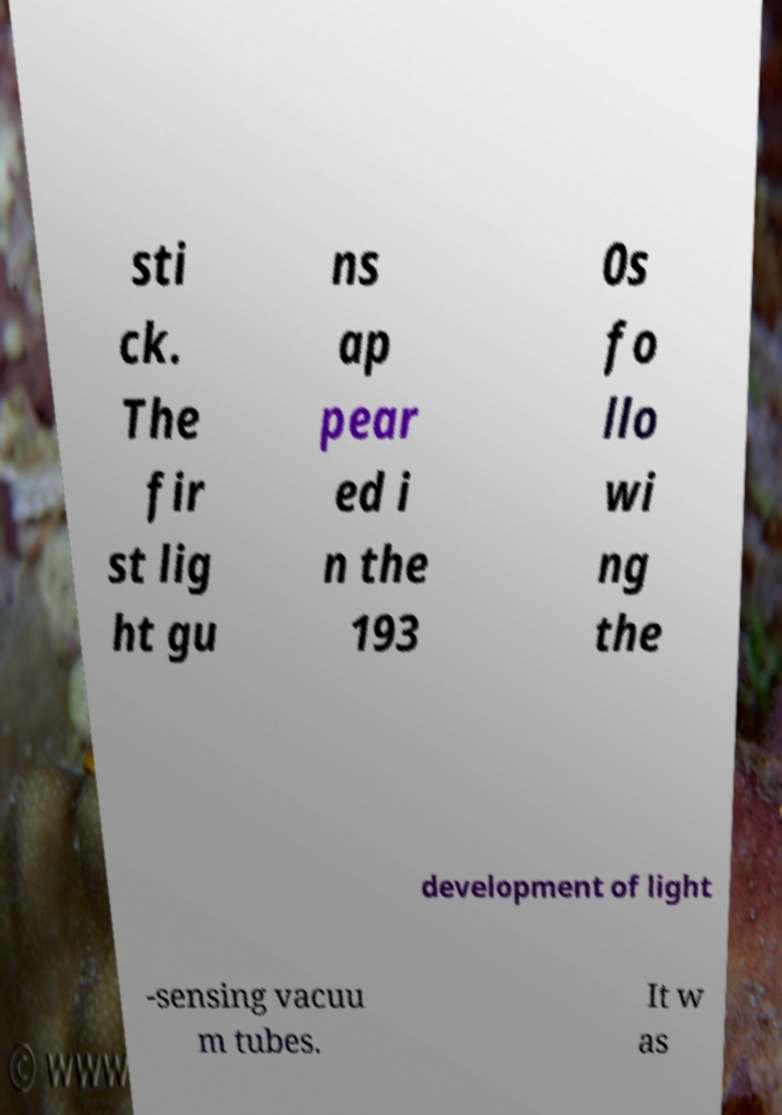Can you accurately transcribe the text from the provided image for me? sti ck. The fir st lig ht gu ns ap pear ed i n the 193 0s fo llo wi ng the development of light -sensing vacuu m tubes. It w as 